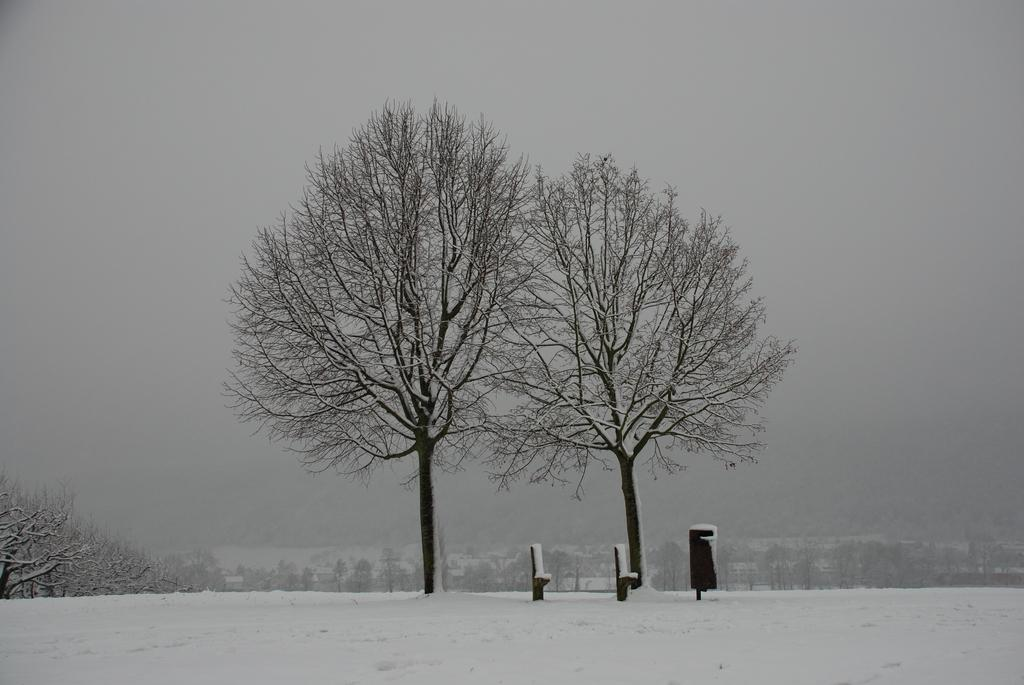What is the primary weather condition depicted in the image? There is snow in the image. What type of natural elements can be seen in the image? There are trees in the image. What is the color of the objects in the image? There are black colored objects in the image. What can be seen in the background of the image? There are trees and fog in the background of the image. How many rings are visible on the trees in the image? There are no rings visible on the trees in the image. What type of knot is being used to secure the snow in the image? There is no knot present in the image, as the snow is not being secured by any object. 